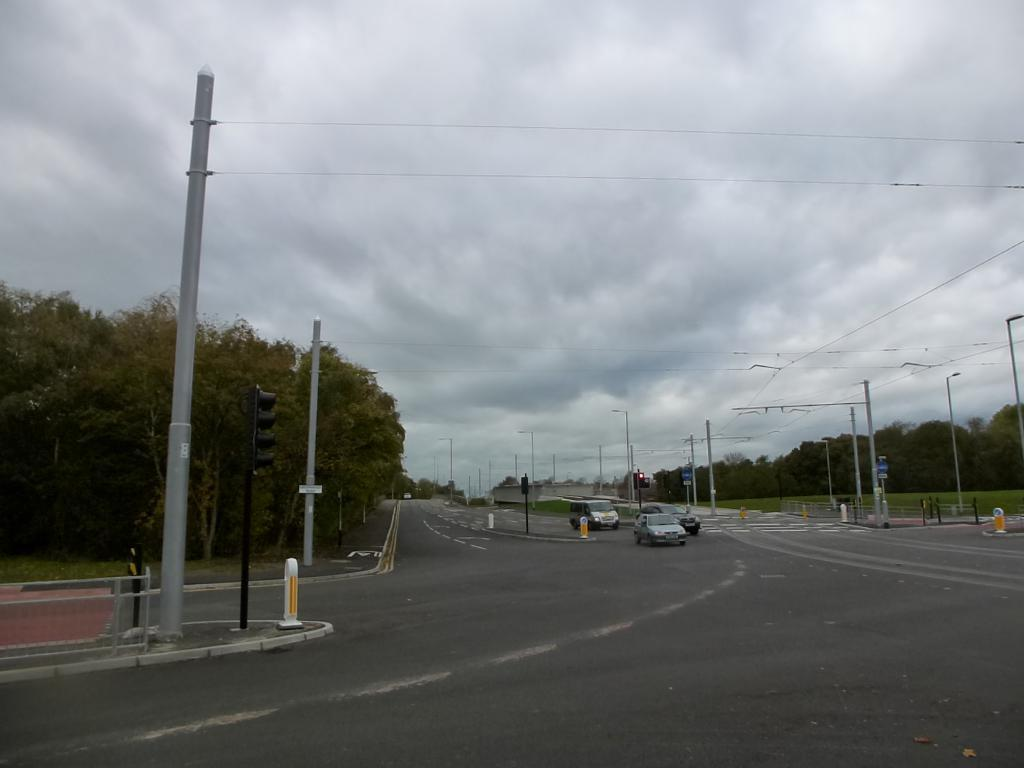What can be seen on the road in the image? There are vehicles on the road in the image. What structures are present in the image? There are poles in the image. What type of vegetation is visible in the image? There are trees in the image. What is the ground covered with in the image? There is grass on the ground in the image. How would you describe the sky in the image? The sky is cloudy in the image. What type of tools does the carpenter have in the image? There is no carpenter present in the image. What title is written on the sign in the image? There is no sign with a title in the image. Is there a gun visible in the image? There is no gun present in the image. 